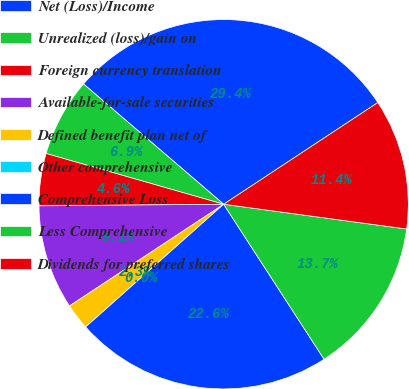Convert chart to OTSL. <chart><loc_0><loc_0><loc_500><loc_500><pie_chart><fcel>Net (Loss)/Income<fcel>Unrealized (loss)/gain on<fcel>Foreign currency translation<fcel>Available-for-sale securities<fcel>Defined benefit plan net of<fcel>Other comprehensive<fcel>Comprehensive Loss<fcel>Less Comprehensive<fcel>Dividends for preferred shares<nl><fcel>29.43%<fcel>6.86%<fcel>4.57%<fcel>9.14%<fcel>2.29%<fcel>0.0%<fcel>22.58%<fcel>13.71%<fcel>11.42%<nl></chart> 